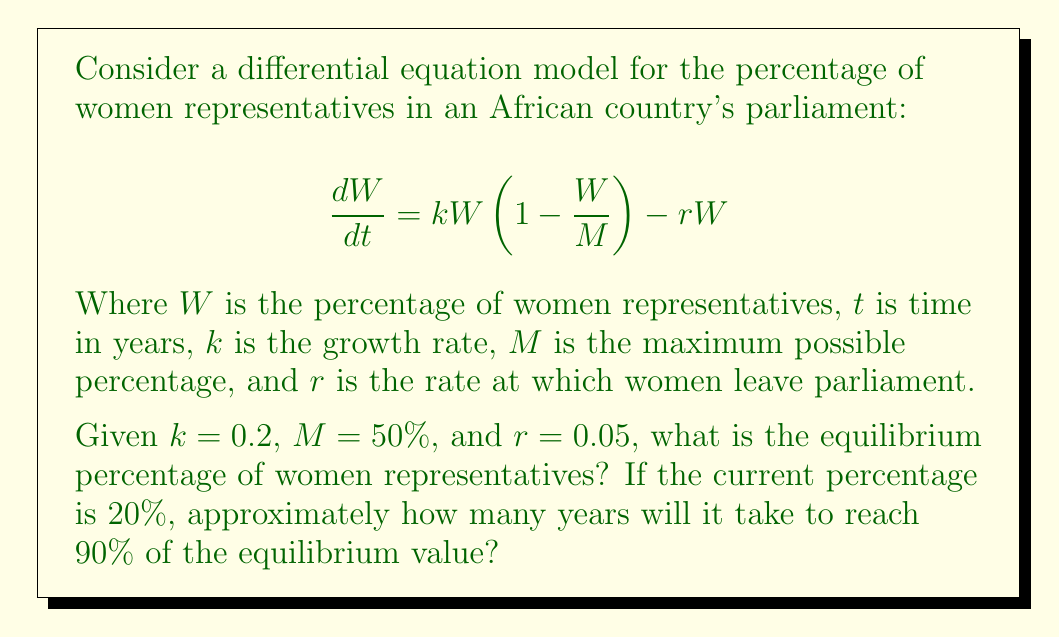Give your solution to this math problem. To solve this problem, we'll follow these steps:

1. Find the equilibrium point by setting $\frac{dW}{dt} = 0$
2. Solve for the equilibrium value of $W$
3. Calculate 90% of the equilibrium value
4. Use the logistic growth formula to estimate the time to reach 90% of the equilibrium

Step 1: Set $\frac{dW}{dt} = 0$
$$0 = kW(1 - \frac{W}{M}) - rW$$

Step 2: Solve for $W$
$$0 = 0.2W(1 - \frac{W}{50}) - 0.05W$$
$$0 = 0.2W - 0.004W^2 - 0.05W$$
$$0 = 0.15W - 0.004W^2$$
$$0.004W^2 = 0.15W$$
$$W(0.004W - 0.15) = 0$$

$W = 0$ or $0.004W - 0.15 = 0$
$W = 37.5\%$

The non-zero equilibrium is 37.5%.

Step 3: Calculate 90% of the equilibrium value
$0.9 * 37.5\% = 33.75\%$

Step 4: Use the logistic growth formula
The logistic growth formula is:
$$W(t) = \frac{KW_0e^{rt}}{K - W_0 + W_0e^{rt}}$$

Where $K$ is the carrying capacity (equilibrium), $W_0$ is the initial value, and $r$ is the intrinsic growth rate.

In our case, $K = 37.5$, $W_0 = 20$, and $r = k - r = 0.2 - 0.05 = 0.15$

We want to find $t$ when $W(t) = 33.75$:

$$33.75 = \frac{37.5 * 20 * e^{0.15t}}{37.5 - 20 + 20 * e^{0.15t}}$$

Solving this equation numerically (using a computer or graphing calculator) gives us $t \approx 10.7$ years.
Answer: The equilibrium percentage of women representatives is 37.5%. It will take approximately 10.7 years to reach 90% of this equilibrium value (33.75%) from the current 20%. 